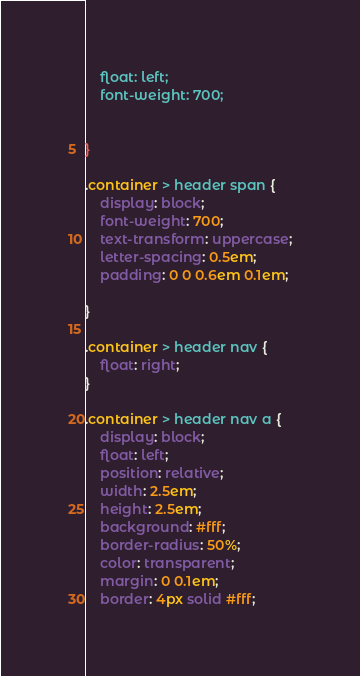Convert code to text. <code><loc_0><loc_0><loc_500><loc_500><_CSS_>	float: left;
	font-weight: 700;


}

.container > header span {
	display: block;
	font-weight: 700;
	text-transform: uppercase;
	letter-spacing: 0.5em;
	padding: 0 0 0.6em 0.1em;

}

.container > header nav {
	float: right;
}

.container > header nav a {
	display: block;
	float: left;
	position: relative;
	width: 2.5em;
	height: 2.5em;
	background: #fff;
	border-radius: 50%;
	color: transparent;
	margin: 0 0.1em;
	border: 4px solid #fff;</code> 